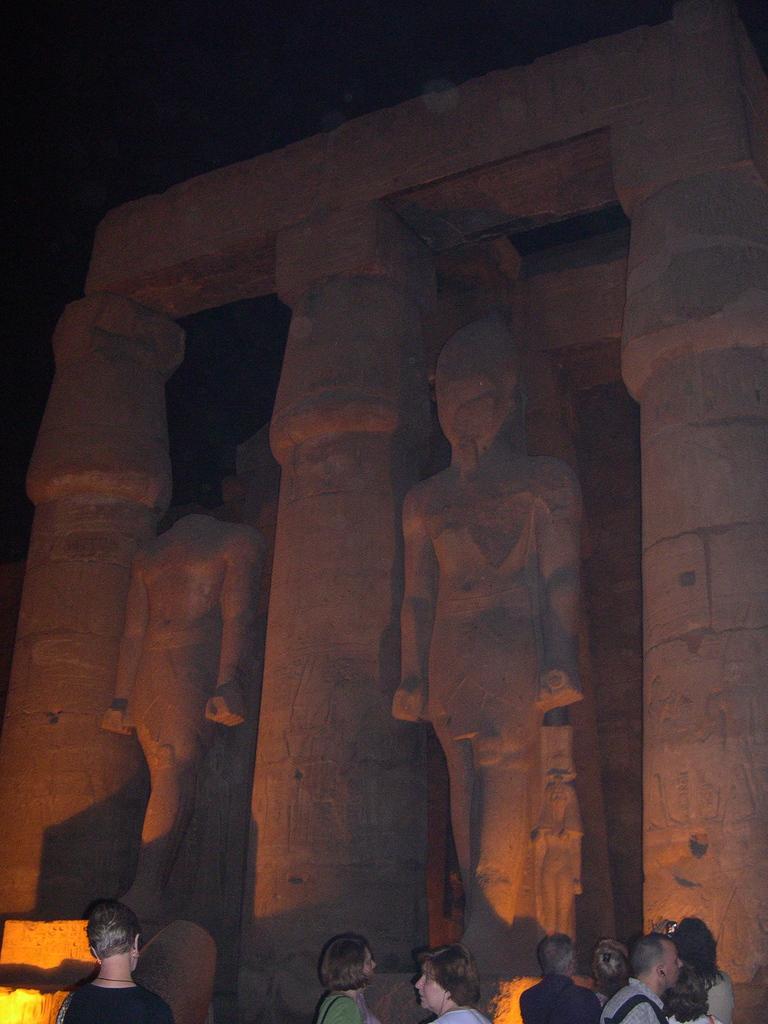Could you give a brief overview of what you see in this image? In this image I can see the group of people with different color dresses. In-front of these people I can see the statues of people. And there is a black background. 